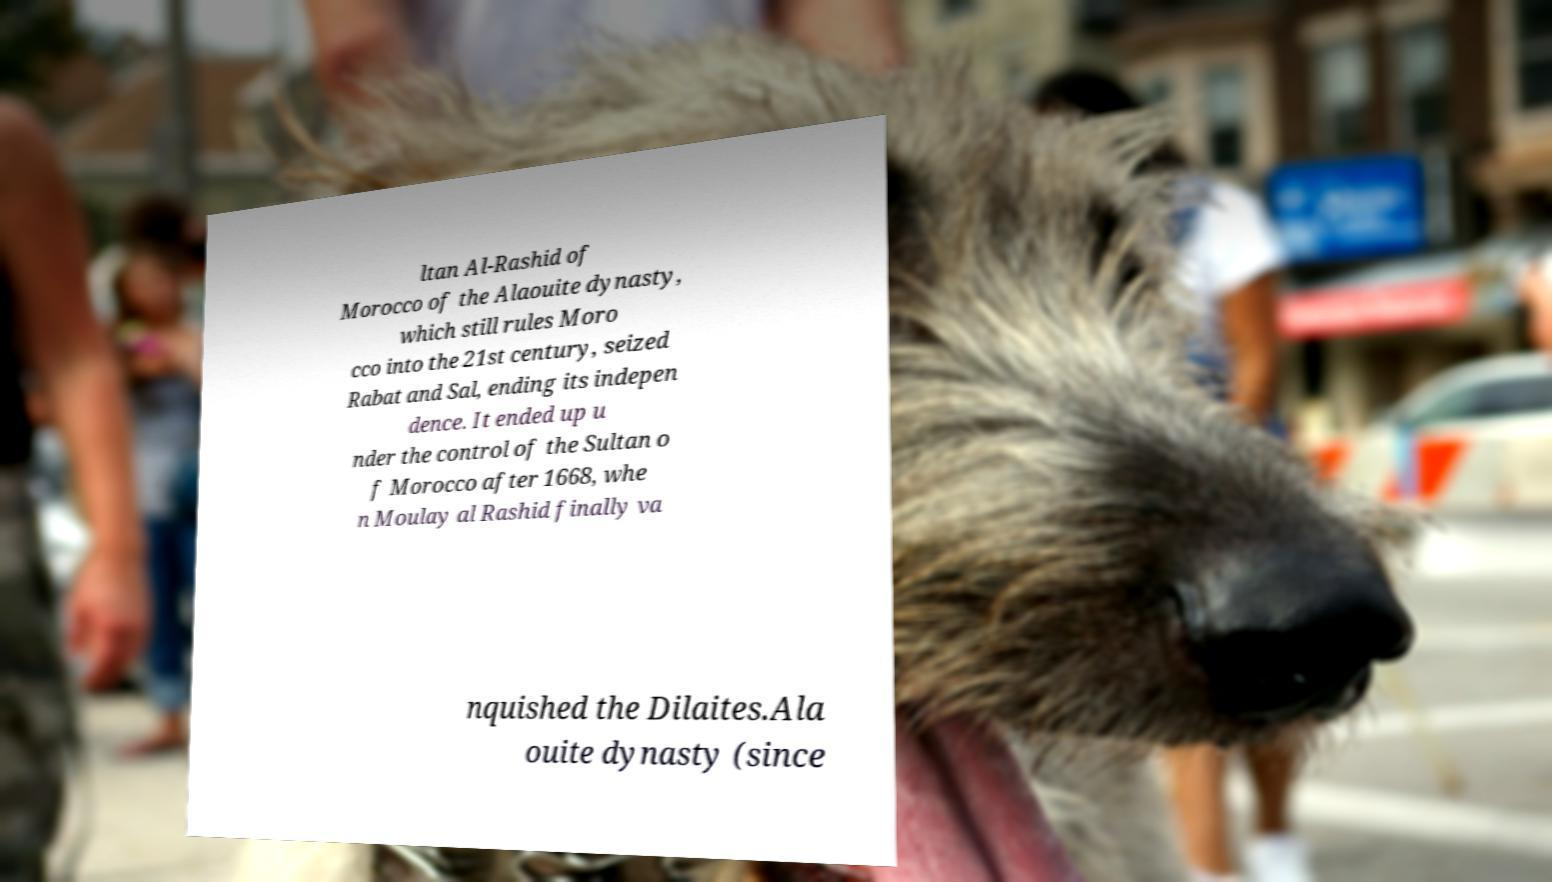Can you accurately transcribe the text from the provided image for me? ltan Al-Rashid of Morocco of the Alaouite dynasty, which still rules Moro cco into the 21st century, seized Rabat and Sal, ending its indepen dence. It ended up u nder the control of the Sultan o f Morocco after 1668, whe n Moulay al Rashid finally va nquished the Dilaites.Ala ouite dynasty (since 